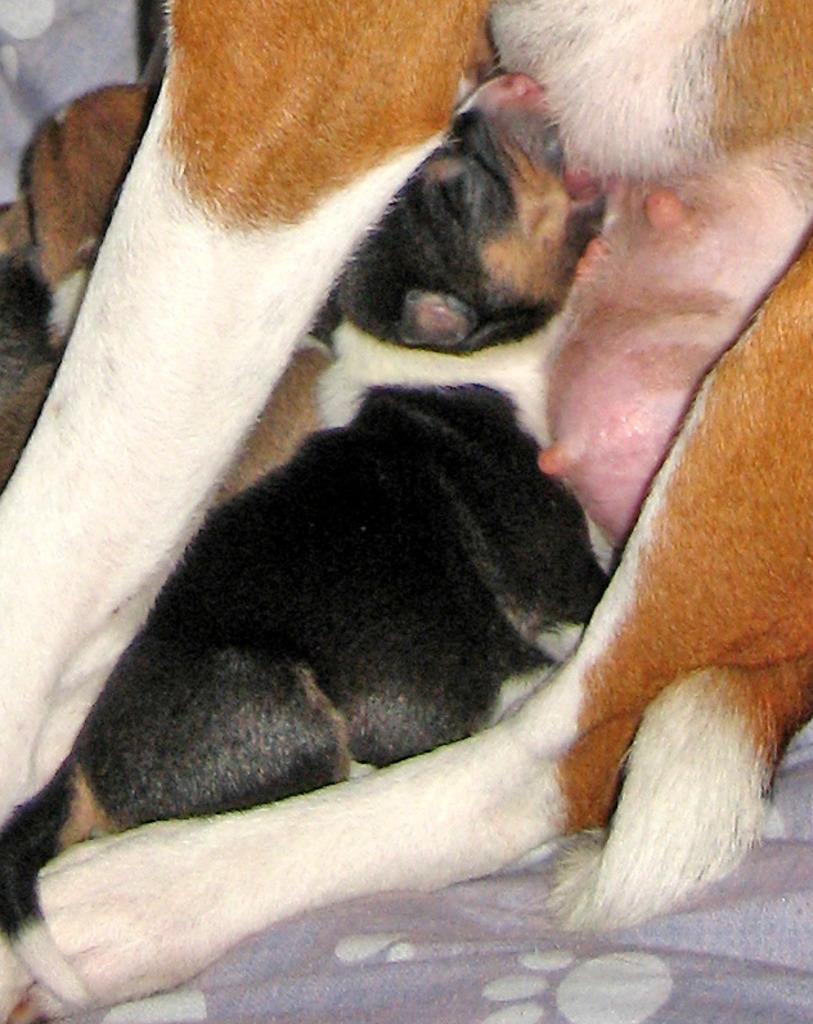Please provide a concise description of this image. In the middle of the image there is a dog and there is a puppy on the bed. 